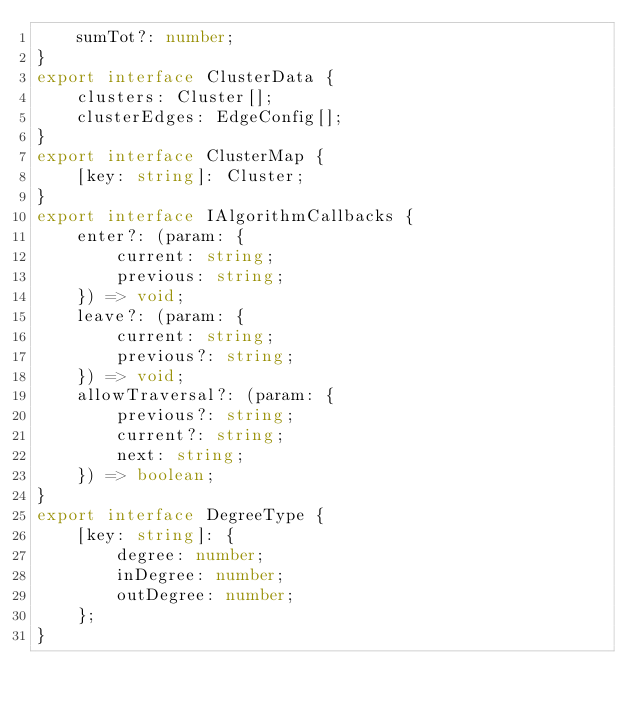Convert code to text. <code><loc_0><loc_0><loc_500><loc_500><_TypeScript_>    sumTot?: number;
}
export interface ClusterData {
    clusters: Cluster[];
    clusterEdges: EdgeConfig[];
}
export interface ClusterMap {
    [key: string]: Cluster;
}
export interface IAlgorithmCallbacks {
    enter?: (param: {
        current: string;
        previous: string;
    }) => void;
    leave?: (param: {
        current: string;
        previous?: string;
    }) => void;
    allowTraversal?: (param: {
        previous?: string;
        current?: string;
        next: string;
    }) => boolean;
}
export interface DegreeType {
    [key: string]: {
        degree: number;
        inDegree: number;
        outDegree: number;
    };
}
</code> 